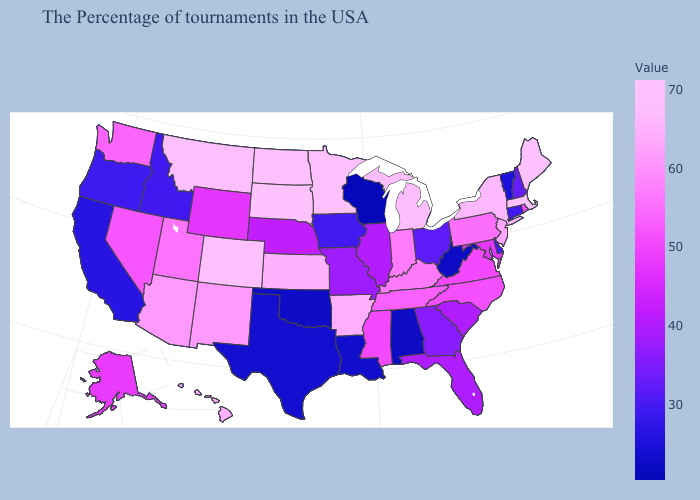Does Mississippi have a higher value than West Virginia?
Quick response, please. Yes. Among the states that border Wyoming , does Idaho have the highest value?
Keep it brief. No. Among the states that border Arizona , does New Mexico have the lowest value?
Concise answer only. No. Which states have the lowest value in the Northeast?
Quick response, please. Vermont. Among the states that border West Virginia , does Pennsylvania have the lowest value?
Quick response, please. No. Does Florida have the lowest value in the USA?
Give a very brief answer. No. 